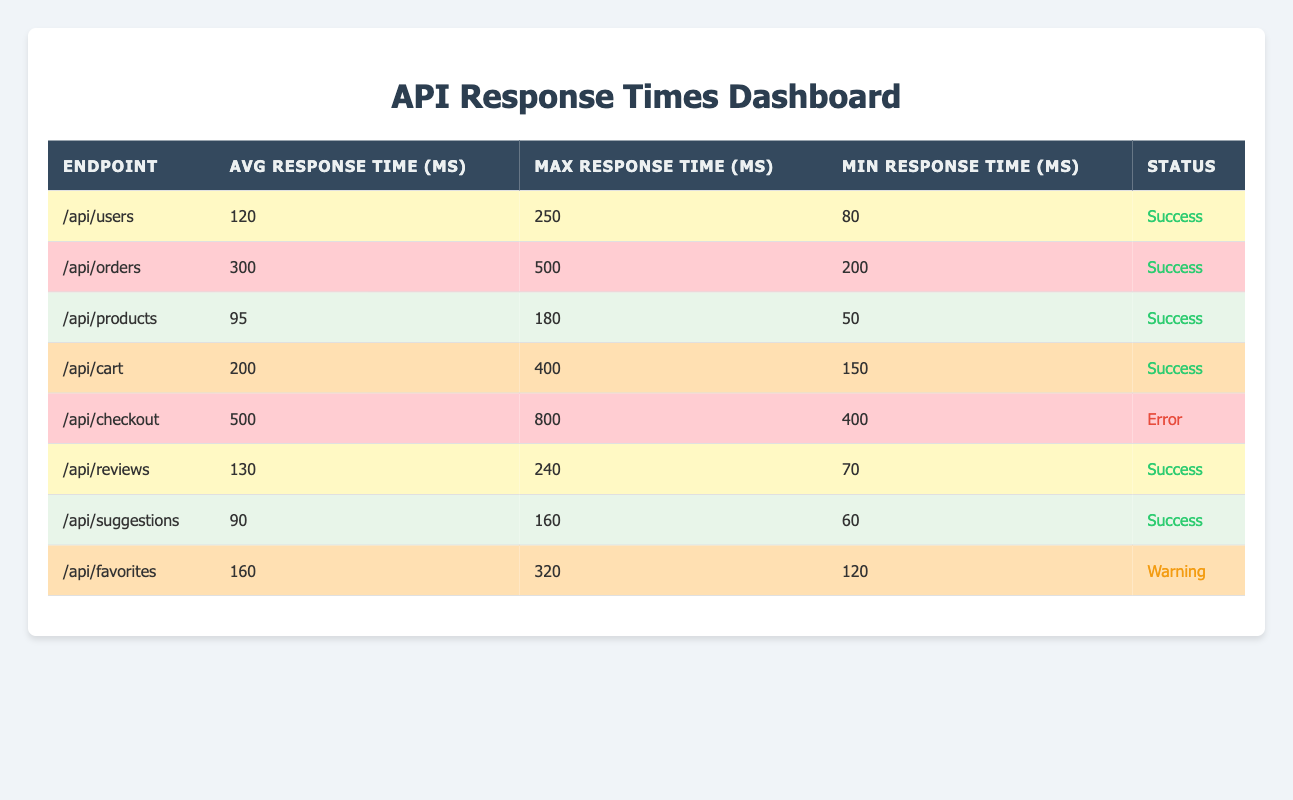What is the average response time for the endpoint "/api/cart"? The average response time for the "/api/cart" endpoint can be found in the table under the "Avg Response Time (ms)" column. The value for this endpoint is 200 ms.
Answer: 200 Which endpoint has the highest maximum response time? To find the endpoint with the highest maximum response time, look at the "Max Response Time (ms)" column. The value is 800 ms for the "/api/checkout" endpoint, which is the highest in the table.
Answer: /api/checkout Is the average response time for "/api/products" less than that of "/api/users"? The average response time for "/api/products" is 95 ms, and for "/api/users" it is 120 ms. Since 95 is less than 120, the answer is yes.
Answer: Yes What is the difference between the maximum response time of "/api/orders" and "/api/cart"? For "/api/orders" the maximum response time is 500 ms and for "/api/cart" it is 400 ms. The difference is computed as 500 - 400 = 100 ms.
Answer: 100 How many endpoints have a response status of "success"? By counting all rows in the table where the status is listed as "success", it can be seen that there are 6 endpoints with this status.
Answer: 6 Which endpoint has a warning status, and what is its average response time? The row for "/api/favorites" has the status "Warning," and its average response time is 160 ms.
Answer: /api/favorites, 160 If we consider only the endpoints with a 'critical' highlight, what is their average maximum response time? The endpoints with a 'critical' highlight are "/api/orders" and "/api/checkout". Their maximum response times are 500 ms and 800 ms respectively. The average is calculated as (500 + 800) / 2 = 650 ms.
Answer: 650 Are there any endpoints that have both a 'warning' highlight and a status of 'error'? By reviewing the table all endpoints with a 'warning' highlight are "/api/cart" and "/api/favorites," while the only one with an 'error' status is "/api/checkout." Hence, there are no overlapping endpoints.
Answer: No What is the minimum response time for any endpoint listed in the table? The minimum response times for each endpoint are: "/api/users" (80 ms), "/api/orders" (200 ms), "/api/products" (50 ms), and others. The smallest value is 50 ms, which belongs to "/api/products". Therefore, the minimum response time is 50 ms.
Answer: 50 What is the overall average response time of all the listed endpoints? To find the overall average response time, sum up all the average response times: (120 + 300 + 95 + 200 + 500 + 130 + 90 + 160) = 1595 ms, then divide by the number of endpoints (8), which results in an overall average of 199.375 ms.
Answer: 199.375 